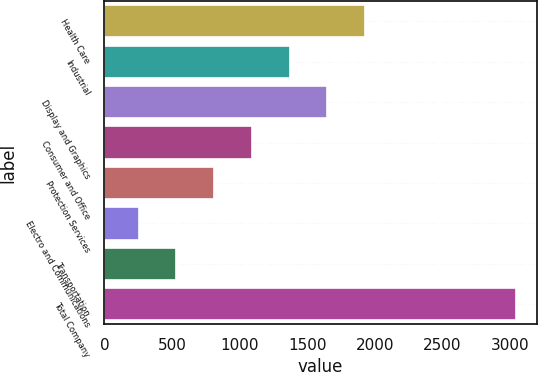<chart> <loc_0><loc_0><loc_500><loc_500><bar_chart><fcel>Health Care<fcel>Industrial<fcel>Display and Graphics<fcel>Consumer and Office<fcel>Protection Services<fcel>Electro and Communications<fcel>Transportation<fcel>Total Company<nl><fcel>1928.8<fcel>1370.2<fcel>1649.5<fcel>1090.9<fcel>811.6<fcel>253<fcel>532.3<fcel>3046<nl></chart> 